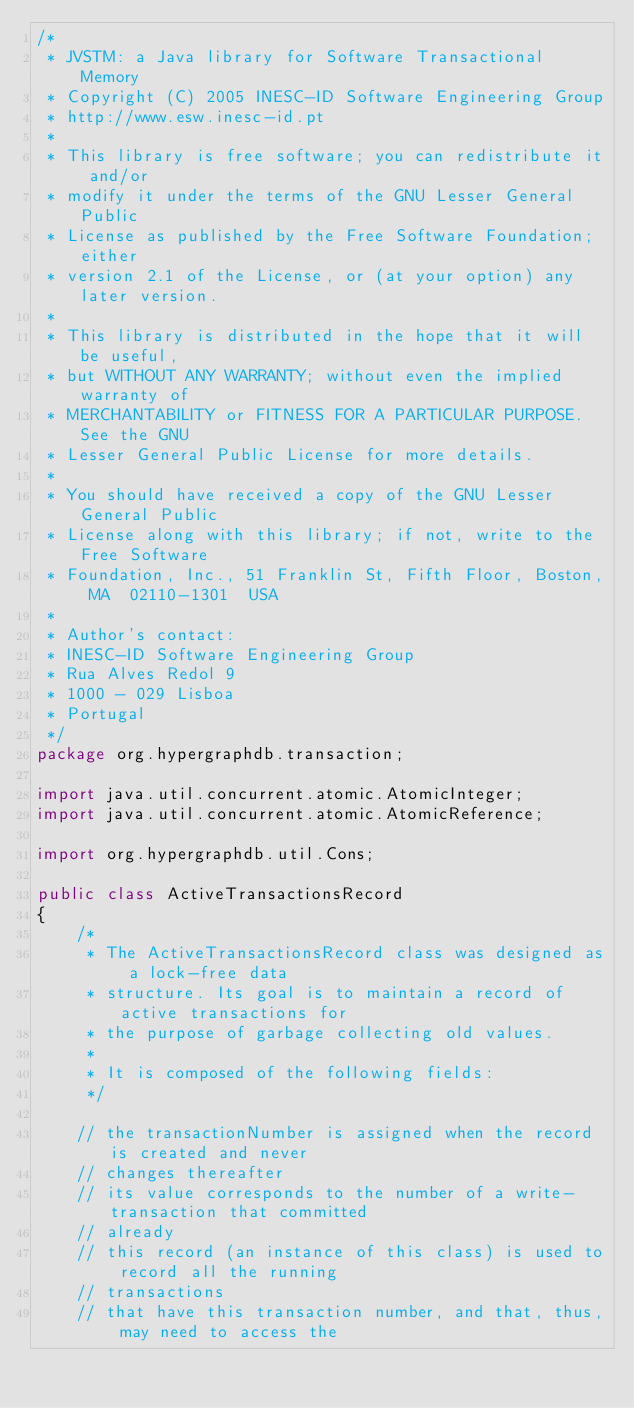<code> <loc_0><loc_0><loc_500><loc_500><_Java_>/*
 * JVSTM: a Java library for Software Transactional Memory
 * Copyright (C) 2005 INESC-ID Software Engineering Group
 * http://www.esw.inesc-id.pt
 *
 * This library is free software; you can redistribute it and/or
 * modify it under the terms of the GNU Lesser General Public
 * License as published by the Free Software Foundation; either
 * version 2.1 of the License, or (at your option) any later version.
 *
 * This library is distributed in the hope that it will be useful,
 * but WITHOUT ANY WARRANTY; without even the implied warranty of
 * MERCHANTABILITY or FITNESS FOR A PARTICULAR PURPOSE.  See the GNU
 * Lesser General Public License for more details.
 *
 * You should have received a copy of the GNU Lesser General Public
 * License along with this library; if not, write to the Free Software
 * Foundation, Inc., 51 Franklin St, Fifth Floor, Boston, MA  02110-1301  USA
 *
 * Author's contact:
 * INESC-ID Software Engineering Group
 * Rua Alves Redol 9
 * 1000 - 029 Lisboa
 * Portugal
 */
package org.hypergraphdb.transaction;

import java.util.concurrent.atomic.AtomicInteger;
import java.util.concurrent.atomic.AtomicReference;

import org.hypergraphdb.util.Cons;

public class ActiveTransactionsRecord
{
    /*
     * The ActiveTransactionsRecord class was designed as a lock-free data
     * structure. Its goal is to maintain a record of active transactions for
     * the purpose of garbage collecting old values.
     * 
     * It is composed of the following fields:
     */

    // the transactionNumber is assigned when the record is created and never
    // changes thereafter
    // its value corresponds to the number of a write-transaction that committed
    // already
    // this record (an instance of this class) is used to record all the running
    // transactions
    // that have this transaction number, and that, thus, may need to access the</code> 